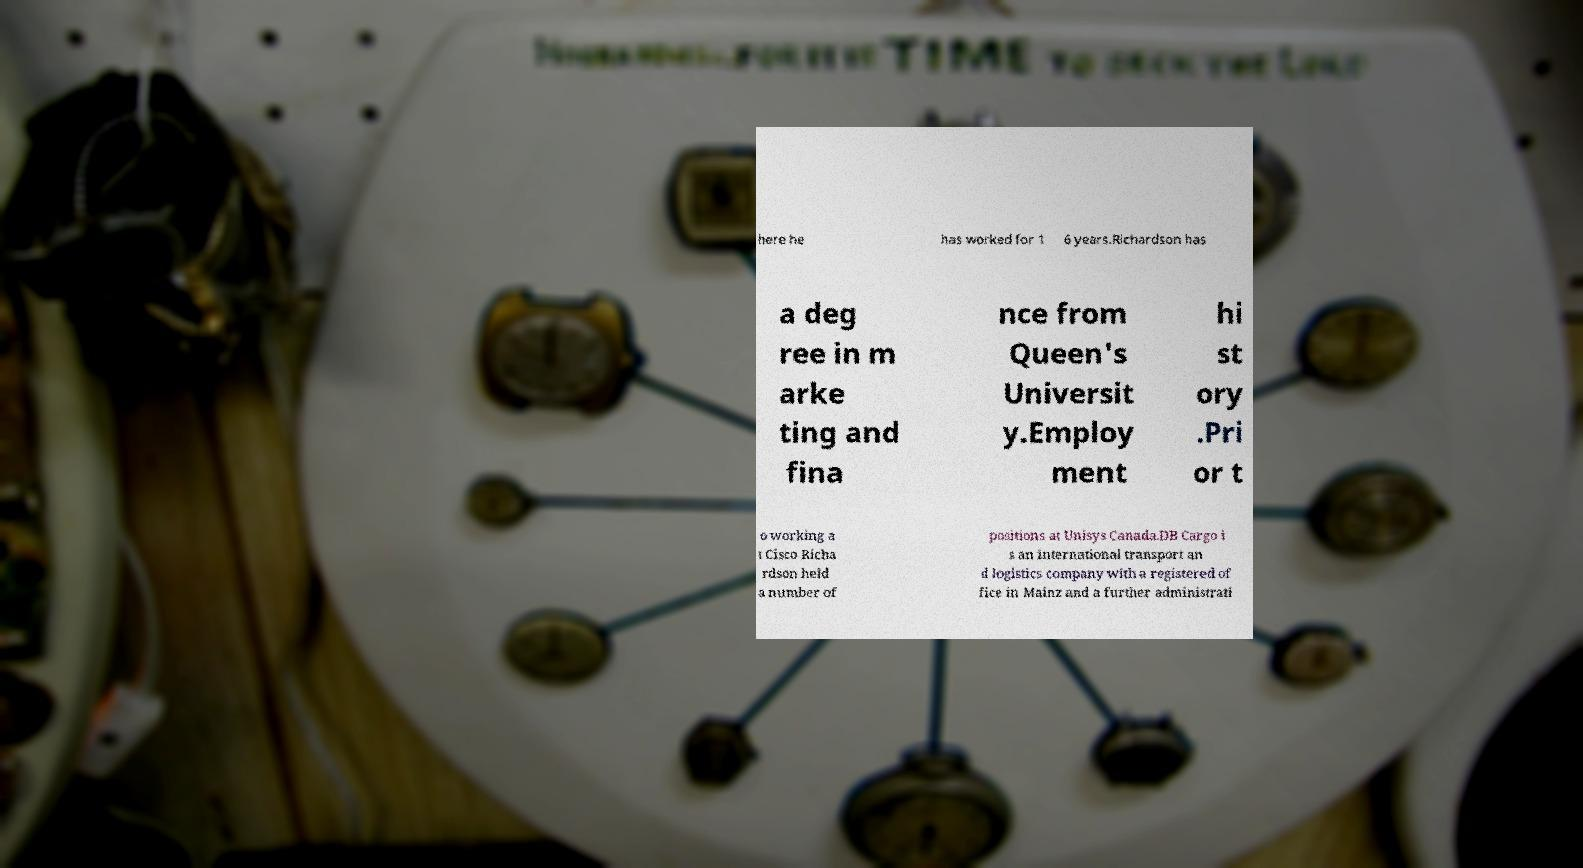Could you extract and type out the text from this image? here he has worked for 1 6 years.Richardson has a deg ree in m arke ting and fina nce from Queen's Universit y.Employ ment hi st ory .Pri or t o working a t Cisco Richa rdson held a number of positions at Unisys Canada.DB Cargo i s an international transport an d logistics company with a registered of fice in Mainz and a further administrati 